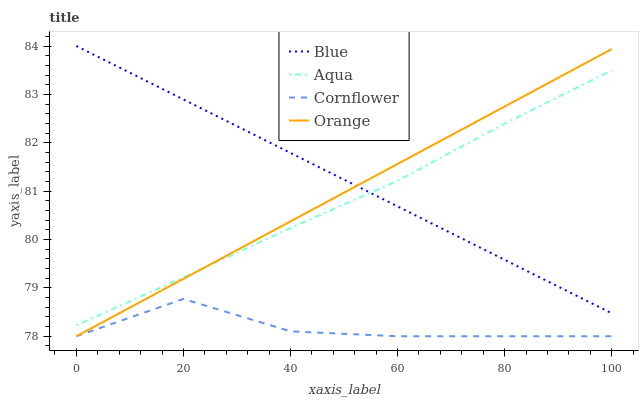Does Cornflower have the minimum area under the curve?
Answer yes or no. Yes. Does Blue have the maximum area under the curve?
Answer yes or no. Yes. Does Orange have the minimum area under the curve?
Answer yes or no. No. Does Orange have the maximum area under the curve?
Answer yes or no. No. Is Orange the smoothest?
Answer yes or no. Yes. Is Cornflower the roughest?
Answer yes or no. Yes. Is Cornflower the smoothest?
Answer yes or no. No. Is Orange the roughest?
Answer yes or no. No. Does Cornflower have the lowest value?
Answer yes or no. Yes. Does Aqua have the lowest value?
Answer yes or no. No. Does Blue have the highest value?
Answer yes or no. Yes. Does Orange have the highest value?
Answer yes or no. No. Is Cornflower less than Blue?
Answer yes or no. Yes. Is Aqua greater than Cornflower?
Answer yes or no. Yes. Does Blue intersect Aqua?
Answer yes or no. Yes. Is Blue less than Aqua?
Answer yes or no. No. Is Blue greater than Aqua?
Answer yes or no. No. Does Cornflower intersect Blue?
Answer yes or no. No. 